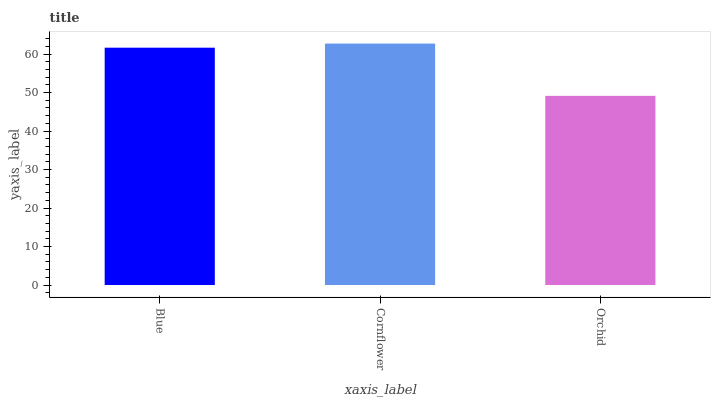Is Orchid the minimum?
Answer yes or no. Yes. Is Cornflower the maximum?
Answer yes or no. Yes. Is Cornflower the minimum?
Answer yes or no. No. Is Orchid the maximum?
Answer yes or no. No. Is Cornflower greater than Orchid?
Answer yes or no. Yes. Is Orchid less than Cornflower?
Answer yes or no. Yes. Is Orchid greater than Cornflower?
Answer yes or no. No. Is Cornflower less than Orchid?
Answer yes or no. No. Is Blue the high median?
Answer yes or no. Yes. Is Blue the low median?
Answer yes or no. Yes. Is Orchid the high median?
Answer yes or no. No. Is Orchid the low median?
Answer yes or no. No. 